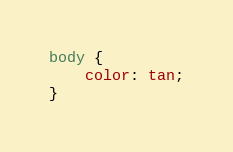<code> <loc_0><loc_0><loc_500><loc_500><_CSS_>body {
    color: tan;
}
</code> 